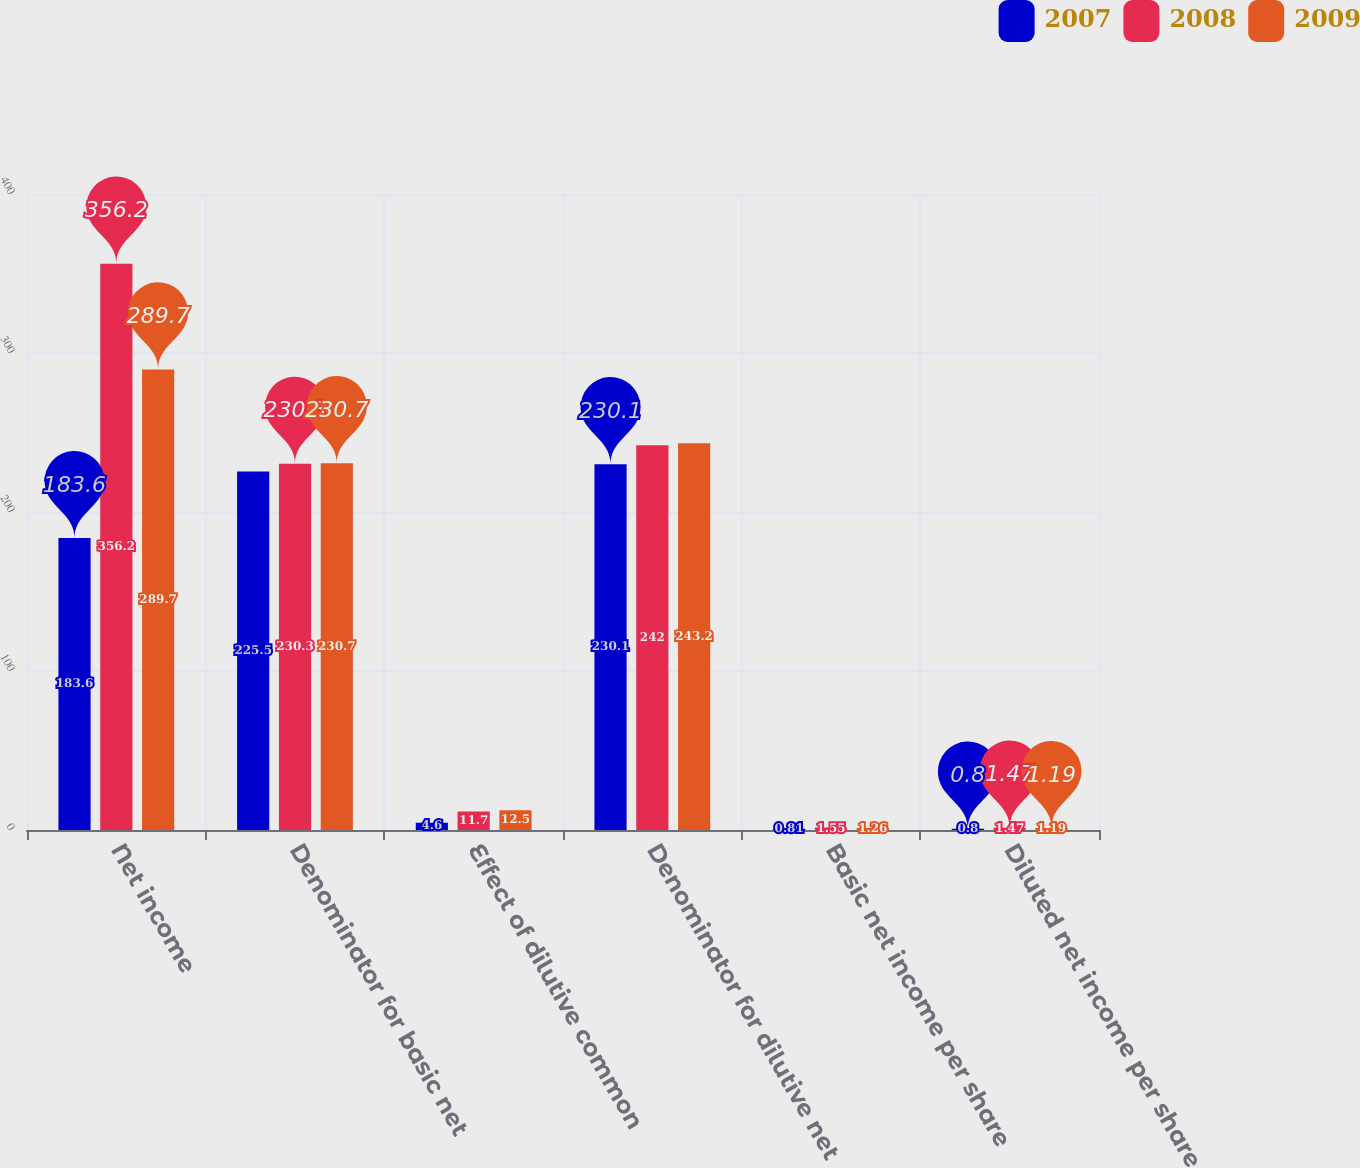Convert chart to OTSL. <chart><loc_0><loc_0><loc_500><loc_500><stacked_bar_chart><ecel><fcel>Net income<fcel>Denominator for basic net<fcel>Effect of dilutive common<fcel>Denominator for dilutive net<fcel>Basic net income per share<fcel>Diluted net income per share<nl><fcel>2007<fcel>183.6<fcel>225.5<fcel>4.6<fcel>230.1<fcel>0.81<fcel>0.8<nl><fcel>2008<fcel>356.2<fcel>230.3<fcel>11.7<fcel>242<fcel>1.55<fcel>1.47<nl><fcel>2009<fcel>289.7<fcel>230.7<fcel>12.5<fcel>243.2<fcel>1.26<fcel>1.19<nl></chart> 